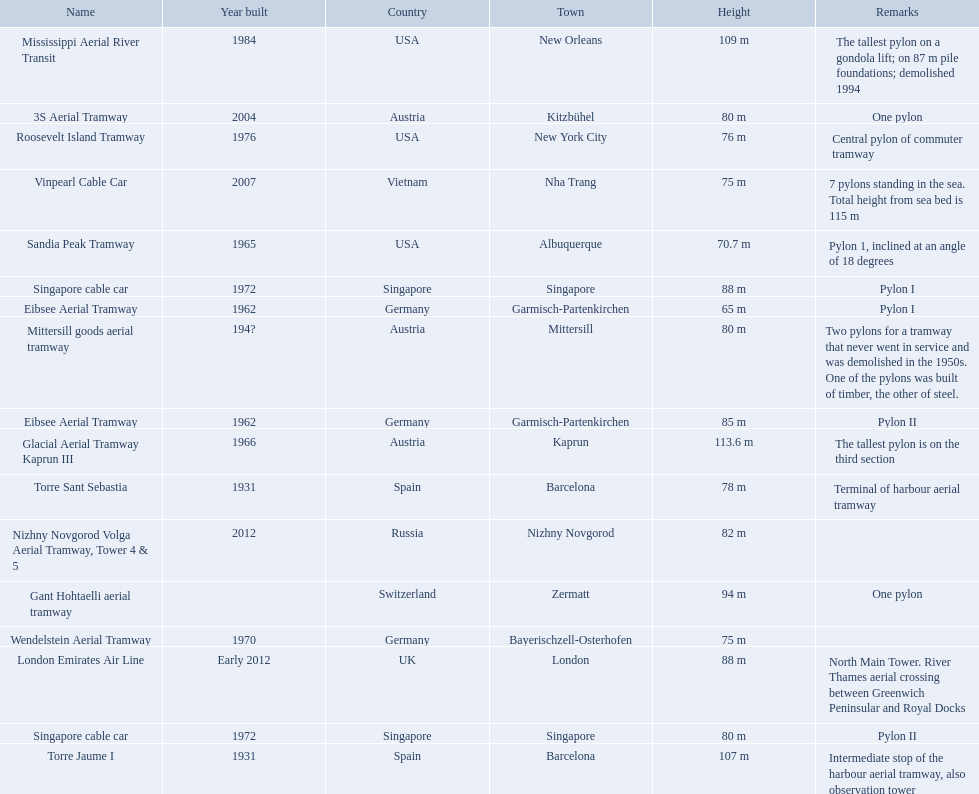Which aerial lifts are over 100 meters tall? Glacial Aerial Tramway Kaprun III, Mississippi Aerial River Transit, Torre Jaume I. Which of those was built last? Mississippi Aerial River Transit. And what is its total height? 109 m. How many aerial lift pylon's on the list are located in the usa? Mississippi Aerial River Transit, Roosevelt Island Tramway, Sandia Peak Tramway. Of the pylon's located in the usa how many were built after 1970? Mississippi Aerial River Transit, Roosevelt Island Tramway. Of the pylon's built after 1970 which is the tallest pylon on a gondola lift? Mississippi Aerial River Transit. How many meters is the tallest pylon on a gondola lift? 109 m. 